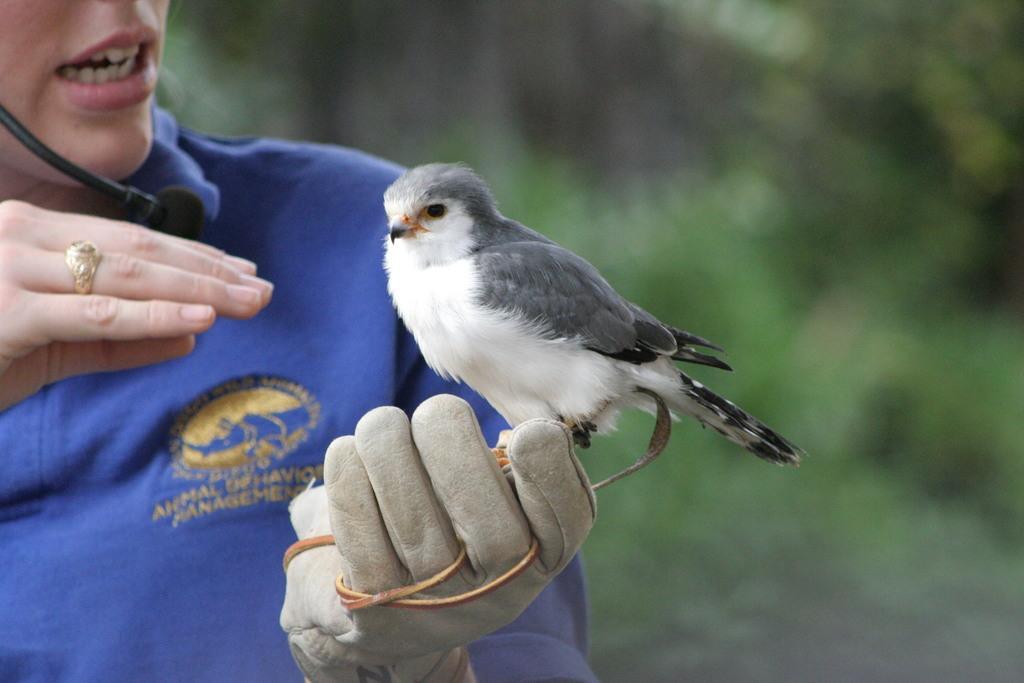Please provide a concise description of this image. There is a person in blue color t-shirt, wearing a black color mic and wearing a glove, on which, there is a bird which is green and white color combination. The background is blurred. 